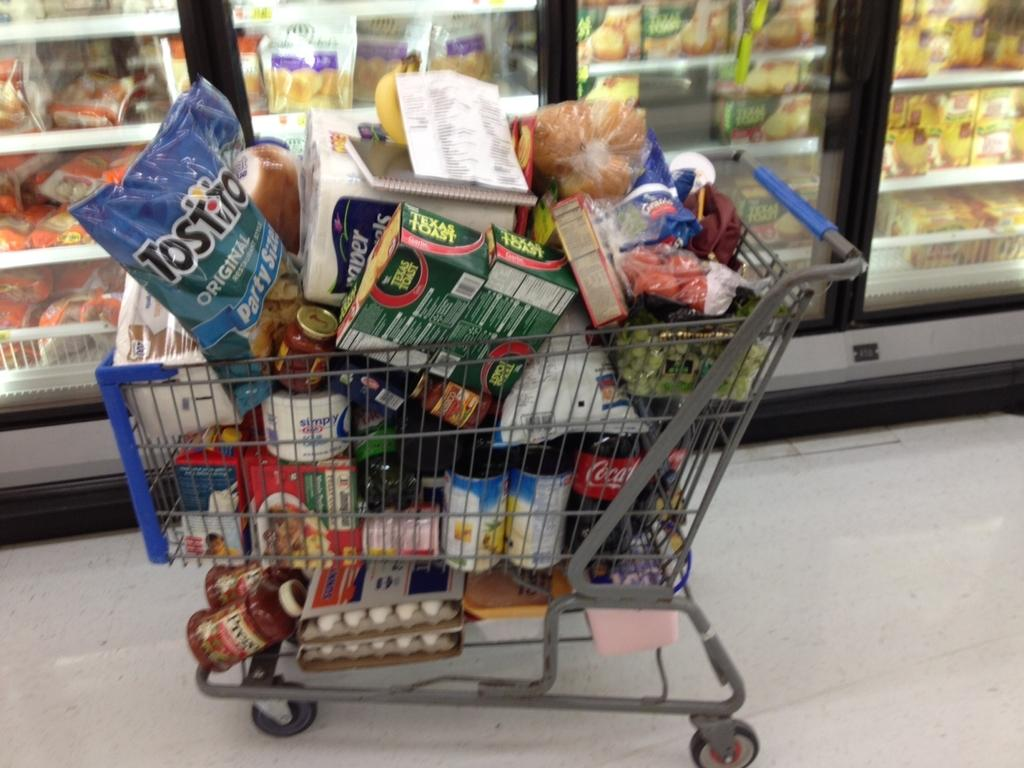Provide a one-sentence caption for the provided image. A shopping cart that is stuffed full of items including Tostito's chips and Coca Cola. 